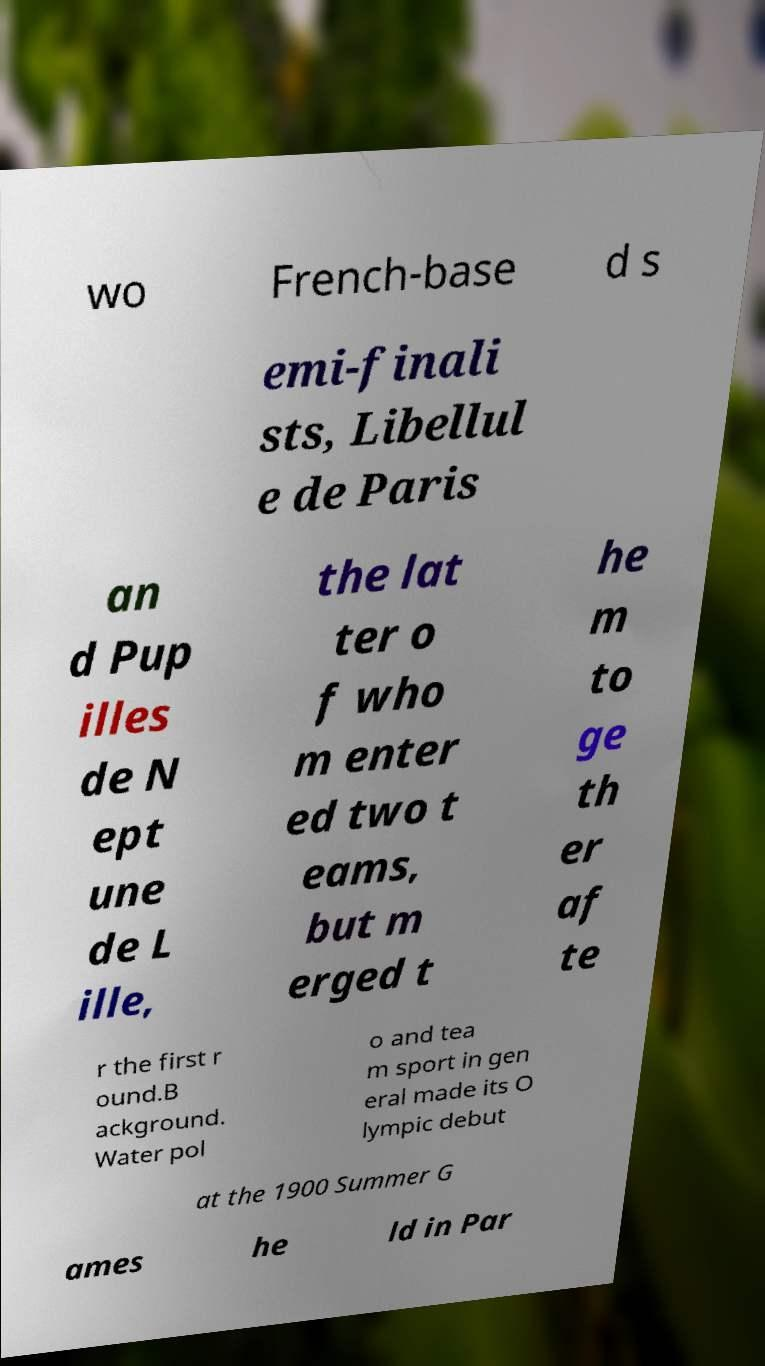There's text embedded in this image that I need extracted. Can you transcribe it verbatim? wo French-base d s emi-finali sts, Libellul e de Paris an d Pup illes de N ept une de L ille, the lat ter o f who m enter ed two t eams, but m erged t he m to ge th er af te r the first r ound.B ackground. Water pol o and tea m sport in gen eral made its O lympic debut at the 1900 Summer G ames he ld in Par 